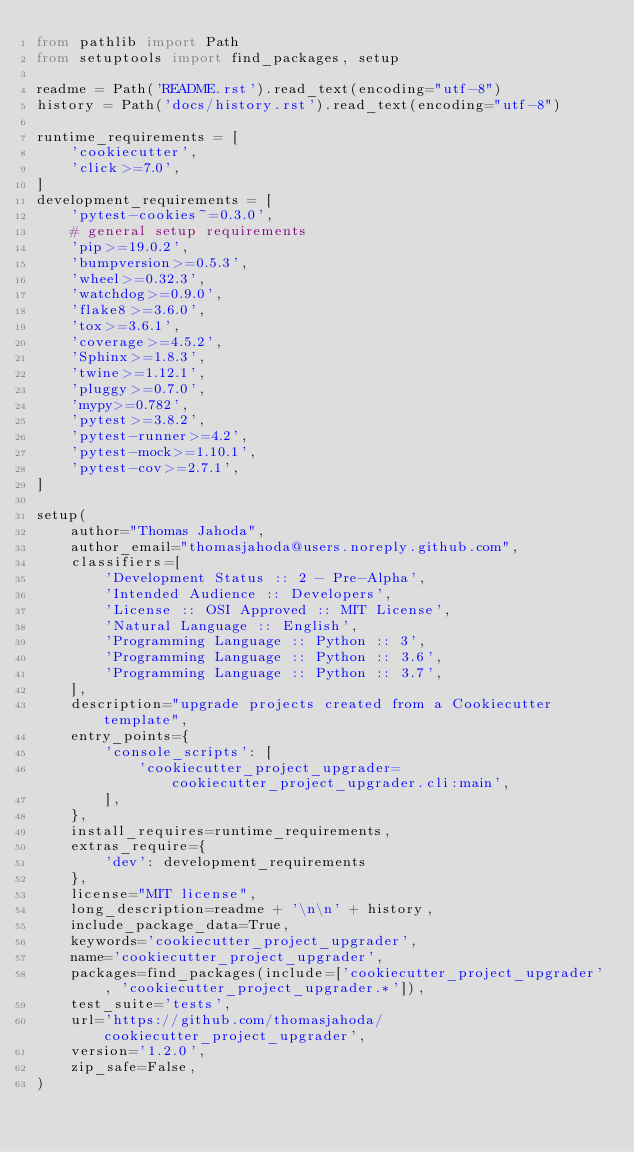<code> <loc_0><loc_0><loc_500><loc_500><_Python_>from pathlib import Path
from setuptools import find_packages, setup

readme = Path('README.rst').read_text(encoding="utf-8")
history = Path('docs/history.rst').read_text(encoding="utf-8")

runtime_requirements = [
    'cookiecutter',
    'click>=7.0',
]
development_requirements = [
    'pytest-cookies~=0.3.0',
    # general setup requirements
    'pip>=19.0.2',
    'bumpversion>=0.5.3',
    'wheel>=0.32.3',
    'watchdog>=0.9.0',
    'flake8>=3.6.0',
    'tox>=3.6.1',
    'coverage>=4.5.2',
    'Sphinx>=1.8.3',
    'twine>=1.12.1',
    'pluggy>=0.7.0',
    'mypy>=0.782',
    'pytest>=3.8.2',
    'pytest-runner>=4.2',
    'pytest-mock>=1.10.1',
    'pytest-cov>=2.7.1',
]

setup(
    author="Thomas Jahoda",
    author_email="thomasjahoda@users.noreply.github.com",
    classifiers=[
        'Development Status :: 2 - Pre-Alpha',
        'Intended Audience :: Developers',
        'License :: OSI Approved :: MIT License',
        'Natural Language :: English',
        'Programming Language :: Python :: 3',
        'Programming Language :: Python :: 3.6',
        'Programming Language :: Python :: 3.7',
    ],
    description="upgrade projects created from a Cookiecutter template",
    entry_points={
        'console_scripts': [
            'cookiecutter_project_upgrader=cookiecutter_project_upgrader.cli:main',
        ],
    },
    install_requires=runtime_requirements,
    extras_require={
        'dev': development_requirements
    },
    license="MIT license",
    long_description=readme + '\n\n' + history,
    include_package_data=True,
    keywords='cookiecutter_project_upgrader',
    name='cookiecutter_project_upgrader',
    packages=find_packages(include=['cookiecutter_project_upgrader', 'cookiecutter_project_upgrader.*']),
    test_suite='tests',
    url='https://github.com/thomasjahoda/cookiecutter_project_upgrader',
    version='1.2.0',
    zip_safe=False,
)
</code> 